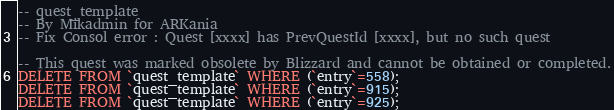Convert code to text. <code><loc_0><loc_0><loc_500><loc_500><_SQL_>-- quest_template
-- By Mikadmin for ARKania
-- Fix Consol error : Quest [xxxx] has PrevQuestId [xxxx], but no such quest

-- This quest was marked obsolete by Blizzard and cannot be obtained or completed.
DELETE FROM `quest_template` WHERE (`entry`=558);
DELETE FROM `quest_template` WHERE (`entry`=915);
DELETE FROM `quest_template` WHERE (`entry`=925);</code> 